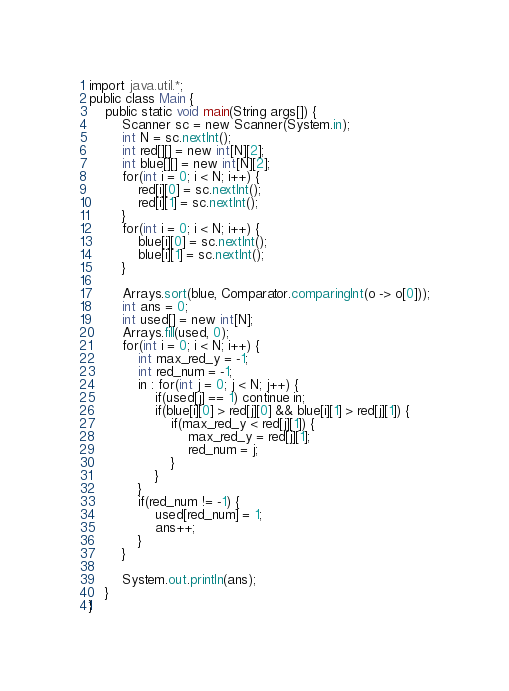Convert code to text. <code><loc_0><loc_0><loc_500><loc_500><_Java_>import java.util.*;
public class Main {
	public static void main(String args[]) {
		Scanner sc = new Scanner(System.in);
		int N = sc.nextInt();
		int red[][] = new int[N][2];
		int blue[][] = new int[N][2];
		for(int i = 0; i < N; i++) {
			red[i][0] = sc.nextInt();
			red[i][1] = sc.nextInt();
		}
		for(int i = 0; i < N; i++) {
			blue[i][0] = sc.nextInt();
			blue[i][1] = sc.nextInt();
		}
		
		Arrays.sort(blue, Comparator.comparingInt(o -> o[0]));
		int ans = 0;
		int used[] = new int[N];
		Arrays.fill(used, 0);
		for(int i = 0; i < N; i++) {
			int max_red_y = -1;
			int red_num = -1;
			in : for(int j = 0; j < N; j++) {
				if(used[j] == 1) continue in;
				if(blue[i][0] > red[j][0] && blue[i][1] > red[j][1]) {
					if(max_red_y < red[j][1]) {
						max_red_y = red[j][1];
						red_num = j;
					}
				}
			}
			if(red_num != -1) {
				used[red_num] = 1;
				ans++;
			}
		}
		
		System.out.println(ans);
	}
}
</code> 